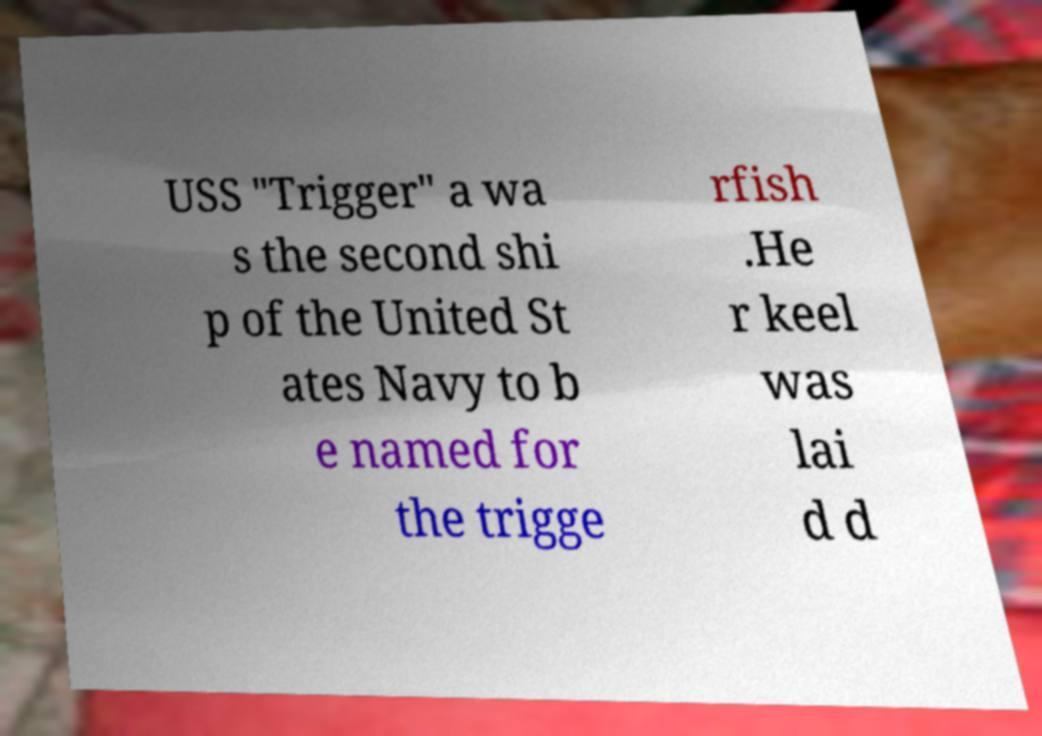Could you assist in decoding the text presented in this image and type it out clearly? USS "Trigger" a wa s the second shi p of the United St ates Navy to b e named for the trigge rfish .He r keel was lai d d 